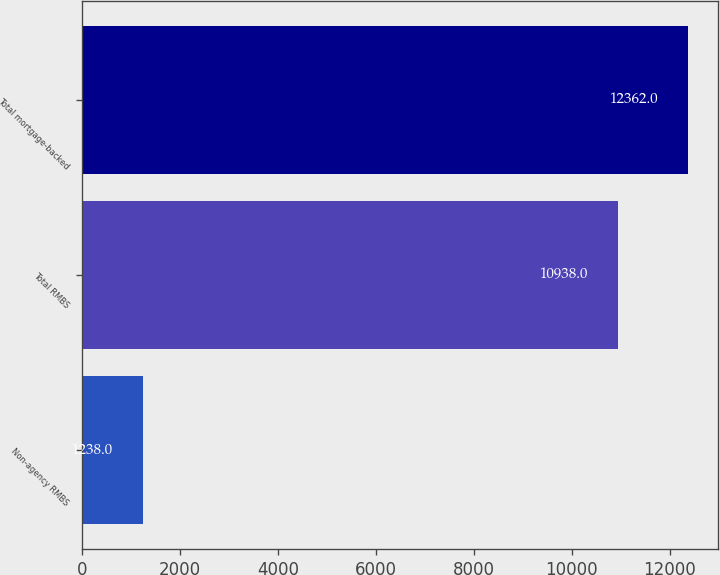<chart> <loc_0><loc_0><loc_500><loc_500><bar_chart><fcel>Non-agency RMBS<fcel>Total RMBS<fcel>Total mortgage-backed<nl><fcel>1238<fcel>10938<fcel>12362<nl></chart> 